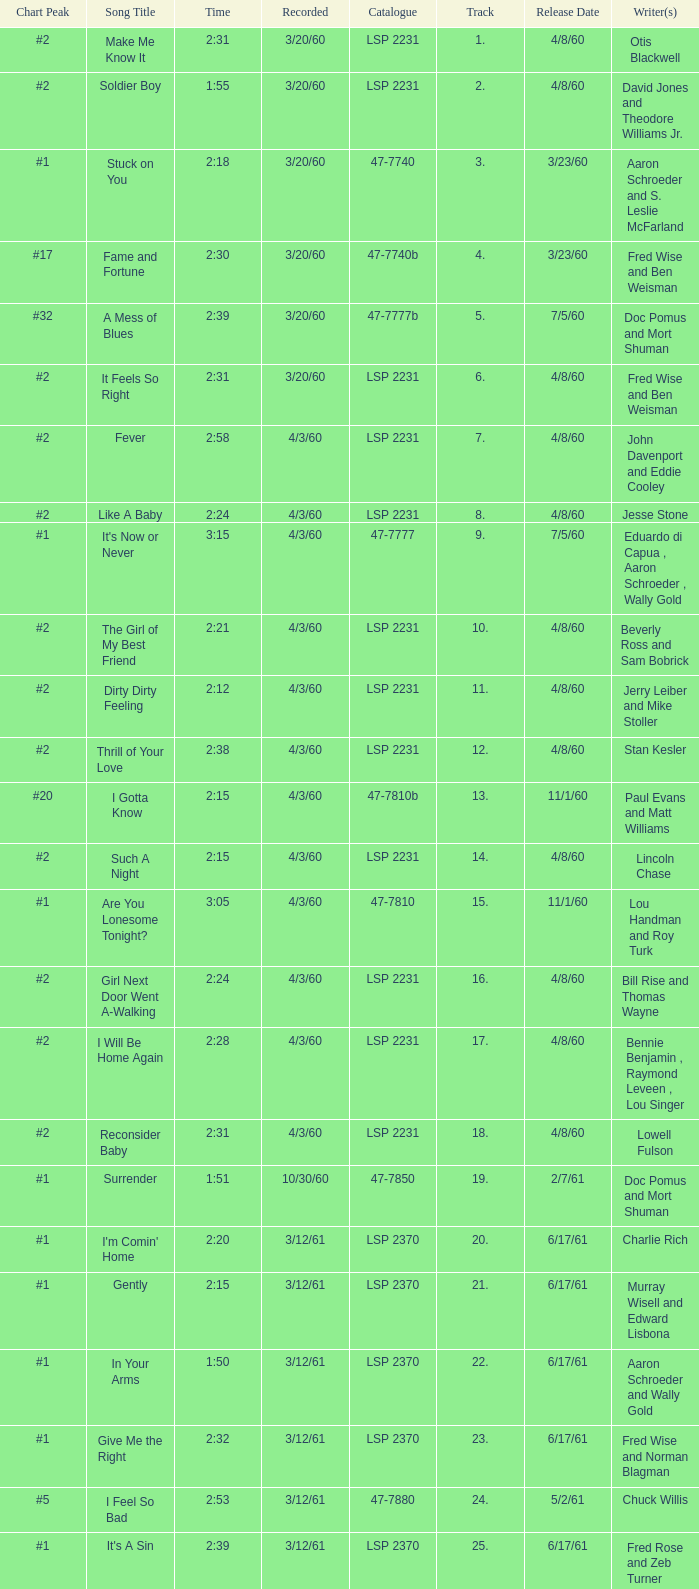What is the time of songs that have the writer Aaron Schroeder and Wally Gold? 1:50. 